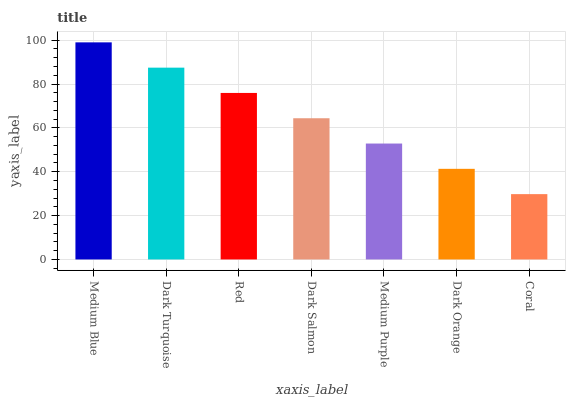Is Coral the minimum?
Answer yes or no. Yes. Is Medium Blue the maximum?
Answer yes or no. Yes. Is Dark Turquoise the minimum?
Answer yes or no. No. Is Dark Turquoise the maximum?
Answer yes or no. No. Is Medium Blue greater than Dark Turquoise?
Answer yes or no. Yes. Is Dark Turquoise less than Medium Blue?
Answer yes or no. Yes. Is Dark Turquoise greater than Medium Blue?
Answer yes or no. No. Is Medium Blue less than Dark Turquoise?
Answer yes or no. No. Is Dark Salmon the high median?
Answer yes or no. Yes. Is Dark Salmon the low median?
Answer yes or no. Yes. Is Medium Blue the high median?
Answer yes or no. No. Is Coral the low median?
Answer yes or no. No. 